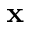<formula> <loc_0><loc_0><loc_500><loc_500>x</formula> 